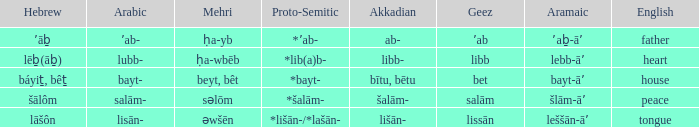If the proto-semitic is *bayt-, what are the geez? Bet. Help me parse the entirety of this table. {'header': ['Hebrew', 'Arabic', 'Mehri', 'Proto-Semitic', 'Akkadian', 'Geez', 'Aramaic', 'English'], 'rows': [['ʼāḇ', 'ʼab-', 'ḥa-yb', '*ʼab-', 'ab-', 'ʼab', 'ʼaḇ-āʼ', 'father'], ['lēḇ(āḇ)', 'lubb-', 'ḥa-wbēb', '*lib(a)b-', 'libb-', 'libb', 'lebb-āʼ', 'heart'], ['báyiṯ, bêṯ', 'bayt-', 'beyt, bêt', '*bayt-', 'bītu, bētu', 'bet', 'bayt-āʼ', 'house'], ['šālôm', 'salām-', 'səlōm', '*šalām-', 'šalām-', 'salām', 'šlām-āʼ', 'peace'], ['lāšôn', 'lisān-', 'əwšēn', '*lišān-/*lašān-', 'lišān-', 'lissān', 'leššān-āʼ', 'tongue']]} 